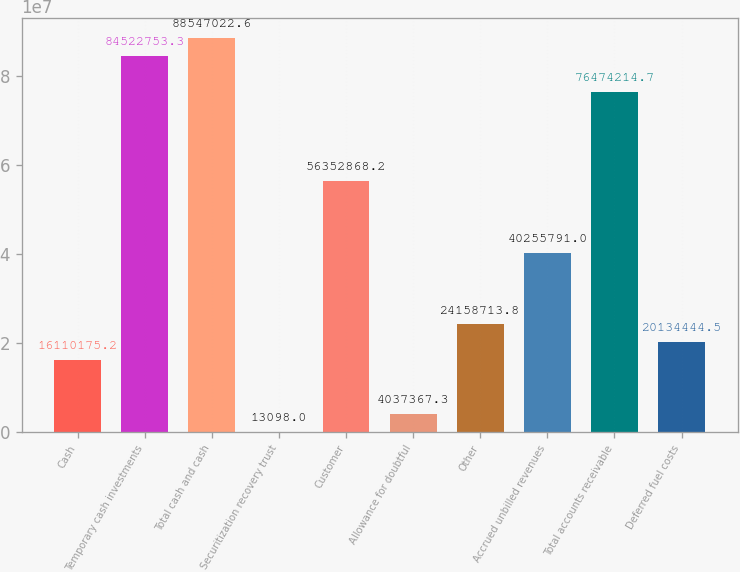Convert chart to OTSL. <chart><loc_0><loc_0><loc_500><loc_500><bar_chart><fcel>Cash<fcel>Temporary cash investments<fcel>Total cash and cash<fcel>Securitization recovery trust<fcel>Customer<fcel>Allowance for doubtful<fcel>Other<fcel>Accrued unbilled revenues<fcel>Total accounts receivable<fcel>Deferred fuel costs<nl><fcel>1.61102e+07<fcel>8.45228e+07<fcel>8.8547e+07<fcel>13098<fcel>5.63529e+07<fcel>4.03737e+06<fcel>2.41587e+07<fcel>4.02558e+07<fcel>7.64742e+07<fcel>2.01344e+07<nl></chart> 